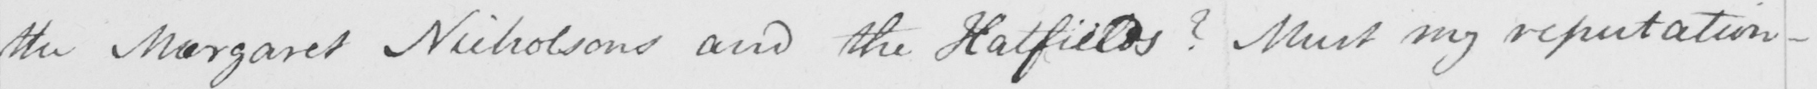What text is written in this handwritten line? the Margaret Nicholsons and the Hatfields ?  Must my reputation  _ 